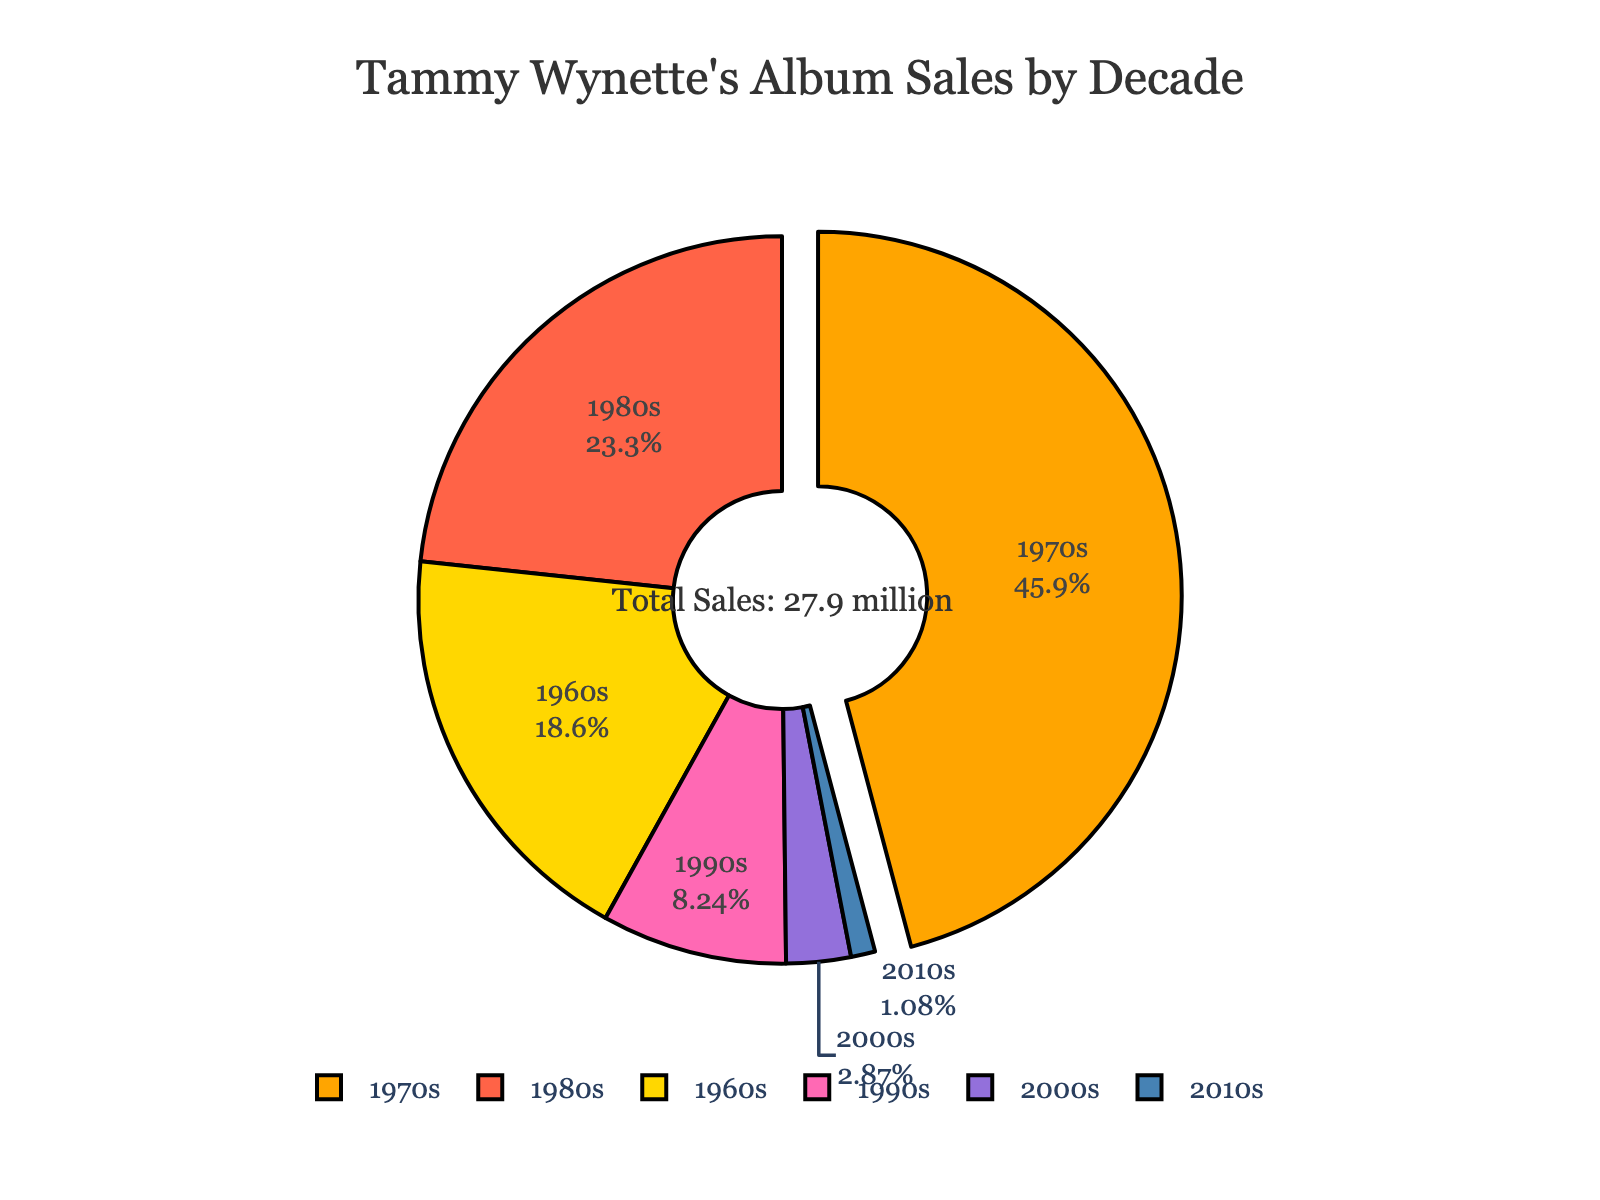Which decade has the highest album sales? The decade with the highest album sales has the largest slice on the pie chart, which is the 1970s.
Answer: 1970s What percentage of album sales occurred in the 1980s? From the text on the pie chart, it can be observed that the slice labeled for the 1980s accounts for a certain percentage of the total album sales. The pie chart shows 23.7%.
Answer: 23.7% How do the album sales in the 2000s compare to those in the 1990s? The pie chart's 2000s slice is smaller than the 1990s slice. Sales were 0.8 million in the 2000s versus 2.3 million in the 1990s.
Answer: The 2000s had fewer sales What is the combined album sales for the 1960s and the 1980s? Adding the sales from the 1960s (5.2 million) and the 1980s (6.5 million): 5.2 + 6.5 = 11.7 million.
Answer: 11.7 million Is the album sales percentage greater in the 1980s or the 1960s? Compare the percentages labeled on the pie chart: the 1980s slice is 23.7% while the 1960s slice is 19%. Therefore, the 1980s have a higher percentage than the 1960s.
Answer: 1980s Which decades have the smallest album sales? The smallest slices on the pie chart belong to the 2010s and the 2000s with sales of 0.3 and 0.8 million, respectively.
Answer: 2010s and 2000s How much did album sales decrease from the 1970s to the 1990s? Subtract the sales of the 1990s (2.3 million) from the 1970s (12.8 million): 12.8 - 2.3 = 10.5 million.
Answer: 10.5 million What is the total album sales across all decades? Summing up all the album sales from each decade: 5.2 + 12.8 + 6.5 + 2.3 + 0.8 + 0.3 = 27.9 million.
Answer: 27.9 million Which slice of the pie is represented in bright pink, and what is its significance? The bright pink slice on the chart corresponds to the 1980s, representing 23.7% of Tammy Wynette's total album sales.
Answer: 1980s, 23.7% 